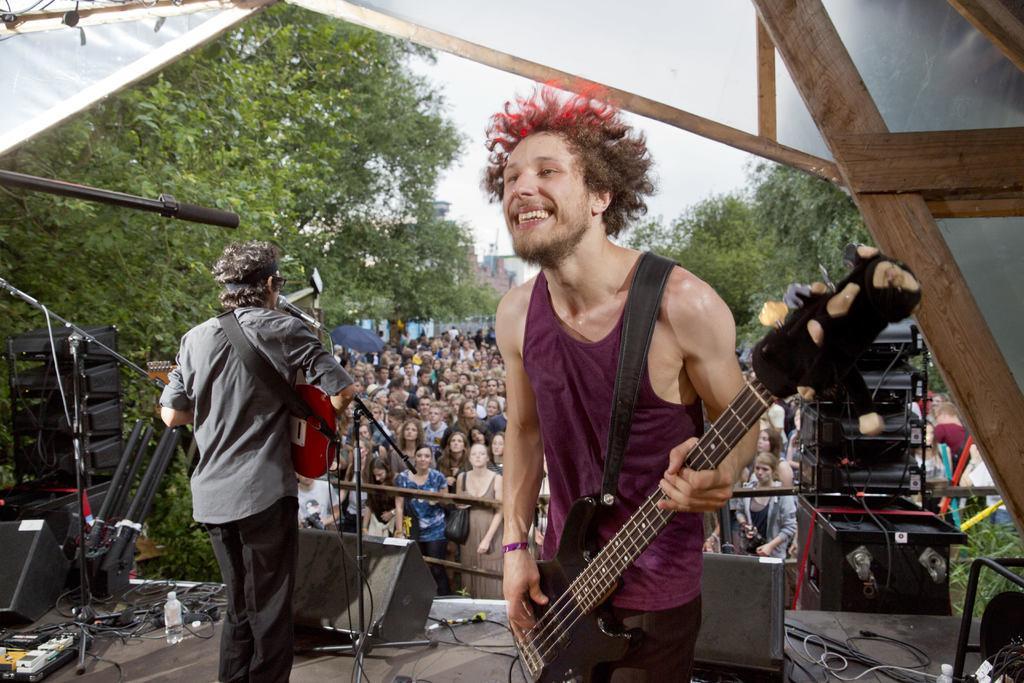How would you summarize this image in a sentence or two? In this image two persons are on the stage standing. Person at the right side is holding a guitar. Middle of image there are group of people standing. There is a mike stand before this person. At the background there is trees and sky. At the left bottom there is a bottle and plug board. 